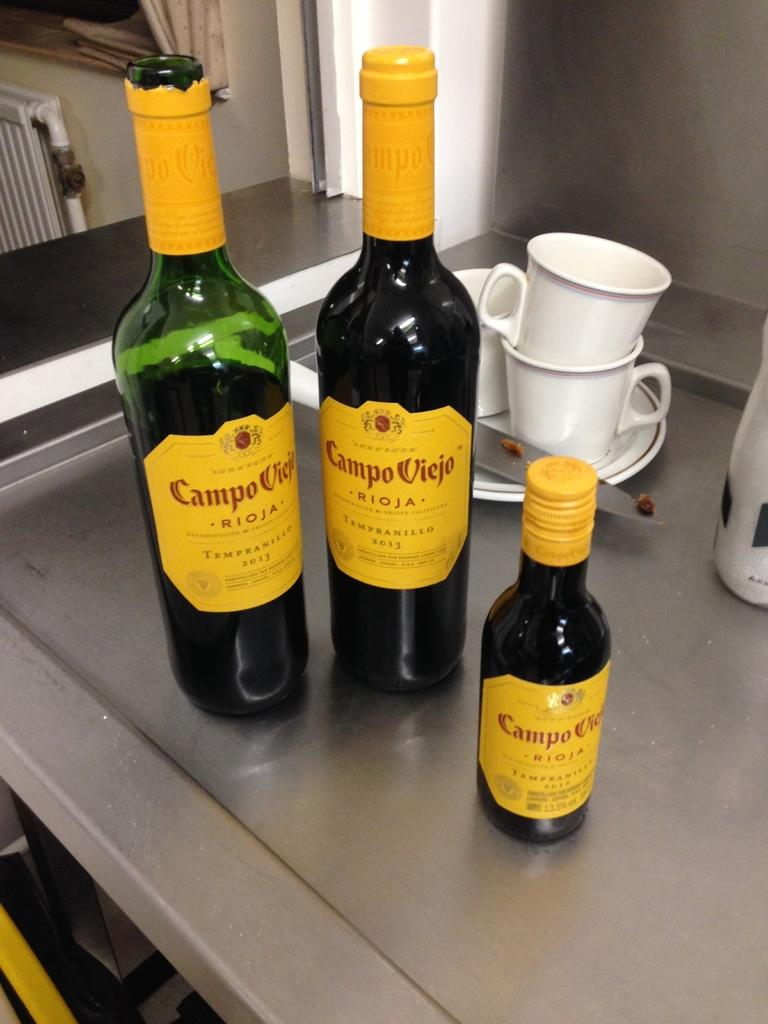<image>
Offer a succinct explanation of the picture presented. Three bottles of Campo Viejo roja sit on a metal counter. 